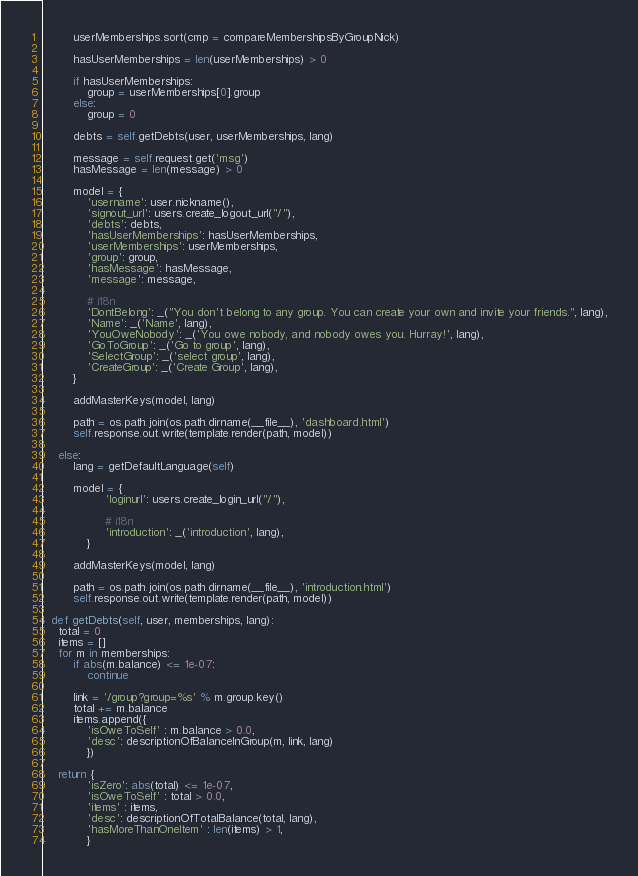<code> <loc_0><loc_0><loc_500><loc_500><_Python_>        userMemberships.sort(cmp = compareMembershipsByGroupNick)
        
        hasUserMemberships = len(userMemberships) > 0
        
        if hasUserMemberships:
            group = userMemberships[0].group
        else:
            group = 0
            
        debts = self.getDebts(user, userMemberships, lang)
        
        message = self.request.get('msg')
        hasMessage = len(message) > 0
        
        model = { 
            'username': user.nickname(),
            'signout_url': users.create_logout_url("/"),
            'debts': debts,
            'hasUserMemberships': hasUserMemberships,
            'userMemberships': userMemberships,
            'group': group,
            'hasMessage': hasMessage,
            'message': message,
            
            # i18n
            'DontBelong': _("You don't belong to any group. You can create your own and invite your friends.", lang),
            'Name': _('Name', lang),
            'YouOweNobody': _('You owe nobody, and nobody owes you. Hurray!', lang),
            'GoToGroup': _('Go to group', lang),
            'SelectGroup': _('select group', lang),
            'CreateGroup': _('Create Group', lang),
        }
        
        addMasterKeys(model, lang)
        
        path = os.path.join(os.path.dirname(__file__), 'dashboard.html')
        self.response.out.write(template.render(path, model))
            
    else:
        lang = getDefaultLanguage(self)
        
        model = {
                 'loginurl': users.create_login_url("/"),
                 
                 # i18n
                 'introduction': _('introduction', lang),
            }
        
        addMasterKeys(model, lang)
        
        path = os.path.join(os.path.dirname(__file__), 'introduction.html')
        self.response.out.write(template.render(path, model))
    
  def getDebts(self, user, memberships, lang):    
    total = 0
    items = []
    for m in memberships:
        if abs(m.balance) <= 1e-07:
            continue
        
        link = '/group?group=%s' % m.group.key()
        total += m.balance
        items.append({
            'isOweToSelf' : m.balance > 0.0, 
            'desc': descriptionOfBalanceInGroup(m, link, lang)
            })
    
    return {
            'isZero': abs(total) <= 1e-07, 
            'isOweToSelf' : total > 0.0, 
            'items' : items,
            'desc': descriptionOfTotalBalance(total, lang),
            'hasMoreThanOneItem' : len(items) > 1,
            }</code> 